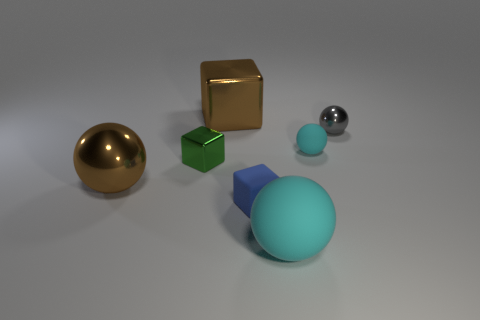How many tiny rubber balls are the same color as the big matte ball?
Ensure brevity in your answer.  1. Is the number of objects on the right side of the tiny matte ball the same as the number of tiny blue balls?
Make the answer very short. No. There is another matte thing that is the same size as the blue thing; what is its color?
Offer a terse response. Cyan. Are there any other small matte things that have the same shape as the tiny blue matte object?
Offer a terse response. No. There is a large ball that is in front of the tiny rubber thing in front of the large shiny object that is on the left side of the brown metallic cube; what is it made of?
Provide a succinct answer. Rubber. How many other objects are there of the same size as the green metallic object?
Your response must be concise. 3. The small rubber block is what color?
Offer a very short reply. Blue. How many metal objects are gray balls or balls?
Ensure brevity in your answer.  2. Is there any other thing that has the same material as the large cyan sphere?
Provide a short and direct response. Yes. There is a brown thing that is on the right side of the metallic sphere that is to the left of the brown thing behind the green thing; what size is it?
Offer a very short reply. Large. 